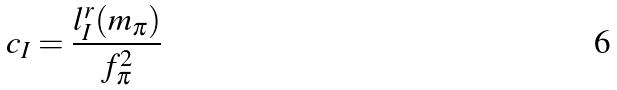<formula> <loc_0><loc_0><loc_500><loc_500>c _ { I } = \frac { l _ { I } ^ { r } ( m _ { \pi } ) } { f _ { \pi } ^ { 2 } }</formula> 